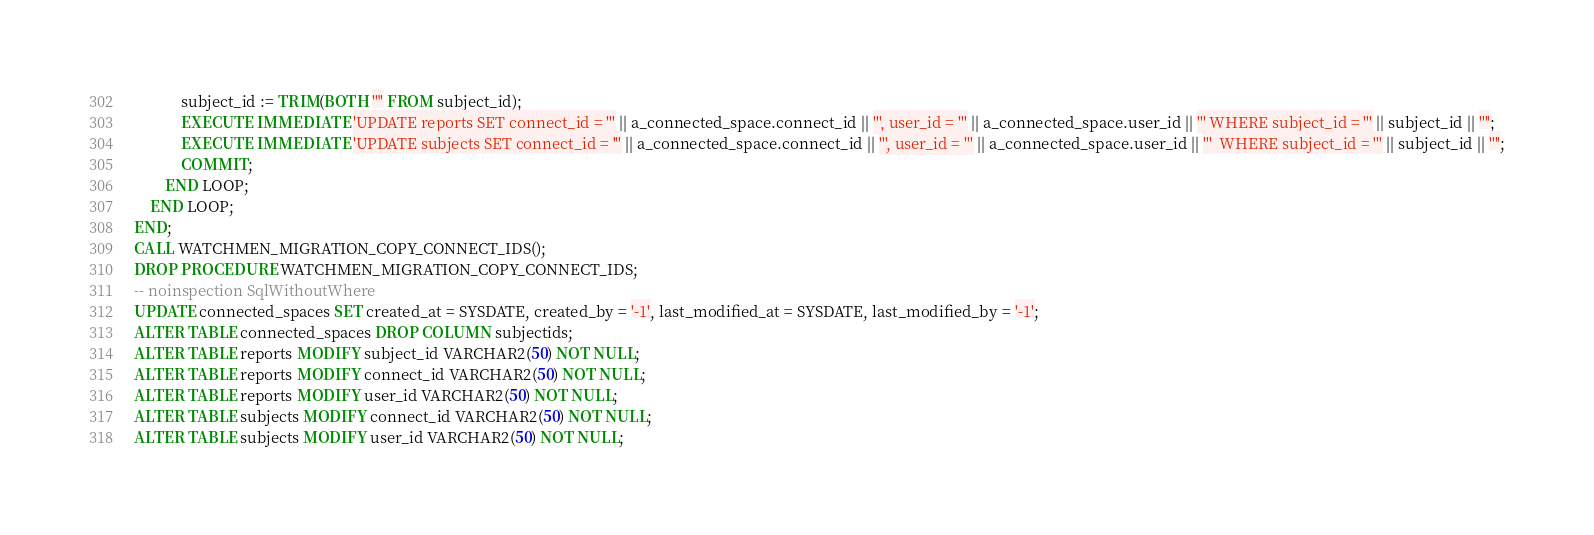Convert code to text. <code><loc_0><loc_0><loc_500><loc_500><_SQL_>            subject_id := TRIM(BOTH '"' FROM subject_id);
            EXECUTE IMMEDIATE 'UPDATE reports SET connect_id = ''' || a_connected_space.connect_id || ''', user_id = ''' || a_connected_space.user_id || ''' WHERE subject_id = ''' || subject_id || '''';
            EXECUTE IMMEDIATE 'UPDATE subjects SET connect_id = ''' || a_connected_space.connect_id || ''', user_id = ''' || a_connected_space.user_id || '''  WHERE subject_id = ''' || subject_id || '''';
            COMMIT;
        END LOOP;
    END LOOP;
END;
CALL WATCHMEN_MIGRATION_COPY_CONNECT_IDS();
DROP PROCEDURE WATCHMEN_MIGRATION_COPY_CONNECT_IDS;
-- noinspection SqlWithoutWhere
UPDATE connected_spaces SET created_at = SYSDATE, created_by = '-1', last_modified_at = SYSDATE, last_modified_by = '-1';
ALTER TABLE connected_spaces DROP COLUMN subjectids;
ALTER TABLE reports MODIFY subject_id VARCHAR2(50) NOT NULL;
ALTER TABLE reports MODIFY connect_id VARCHAR2(50) NOT NULL;
ALTER TABLE reports MODIFY user_id VARCHAR2(50) NOT NULL;
ALTER TABLE subjects MODIFY connect_id VARCHAR2(50) NOT NULL;
ALTER TABLE subjects MODIFY user_id VARCHAR2(50) NOT NULL;
</code> 